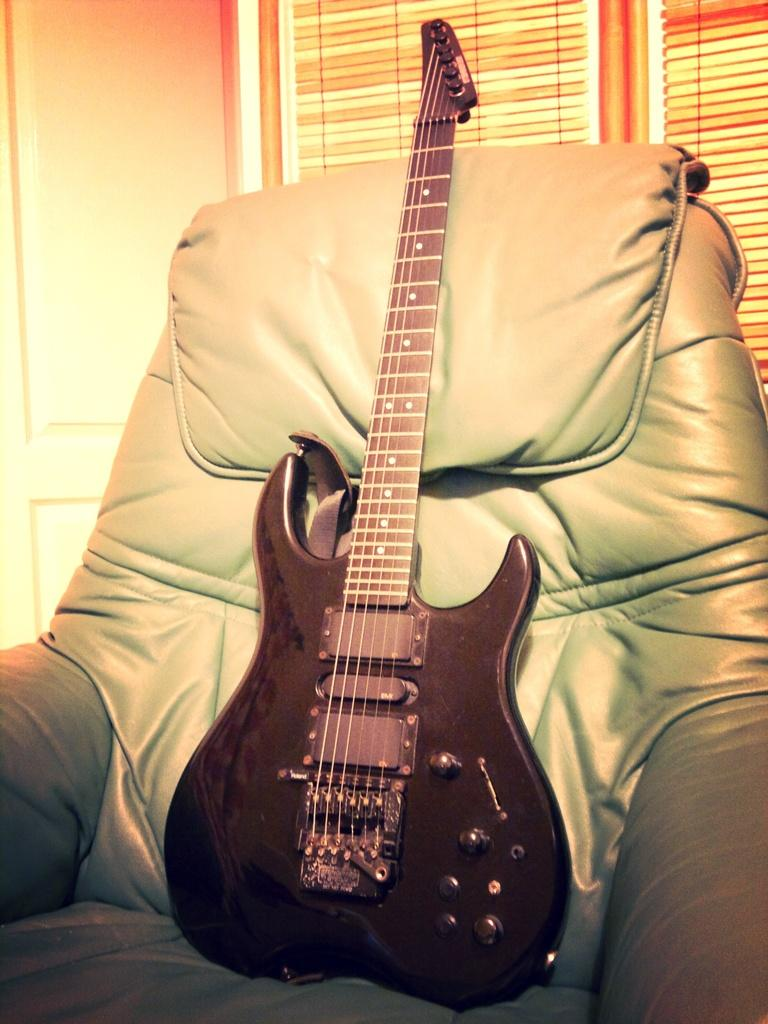What musical instrument is present in the image? There is a guitar in the image. Where is the guitar located? The guitar is on a chair. What can be seen on the window in the image? There are blinds on the window in the image. How many pieces of coal are scattered around the guitar in the image? There is no coal present in the image. What type of toy is sitting next to the guitar in the image? There is no toy present in the image. 